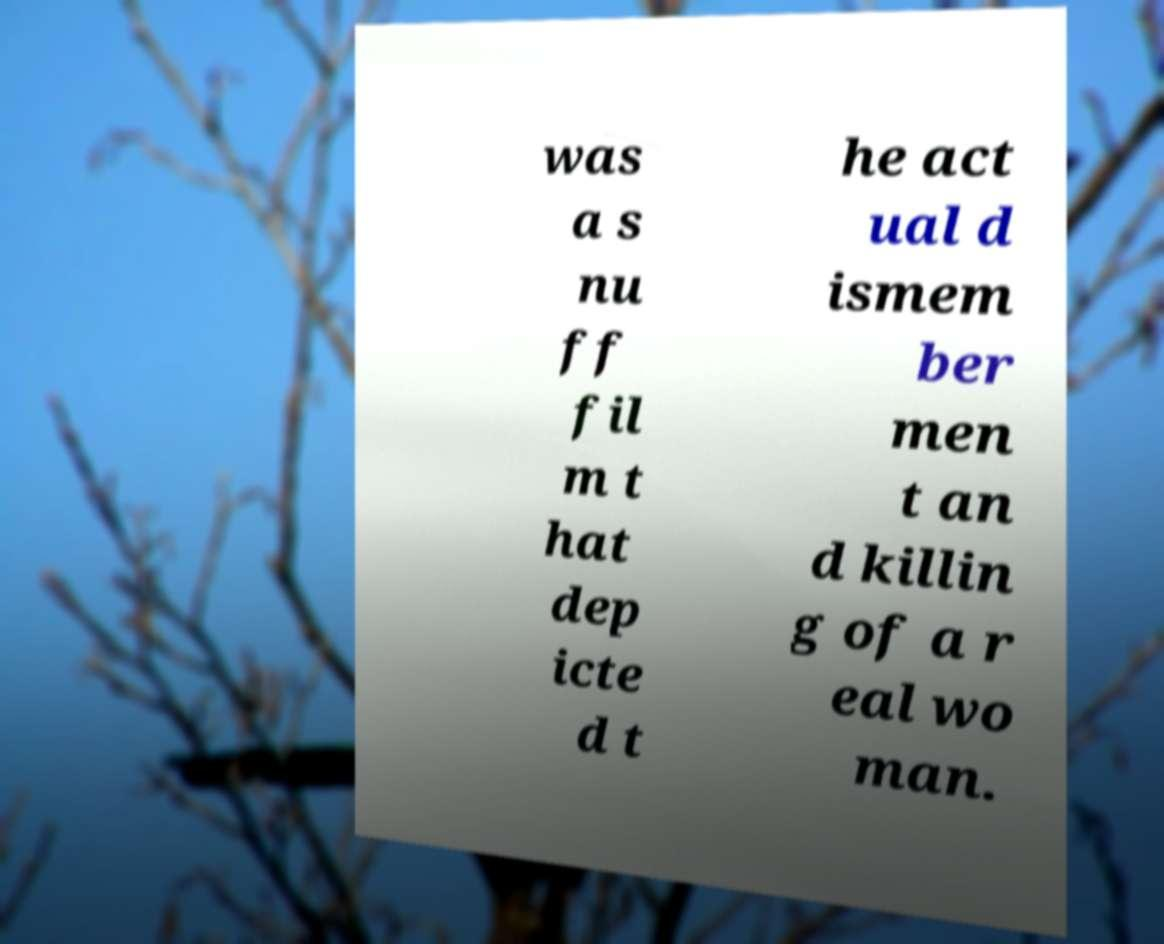Could you extract and type out the text from this image? was a s nu ff fil m t hat dep icte d t he act ual d ismem ber men t an d killin g of a r eal wo man. 